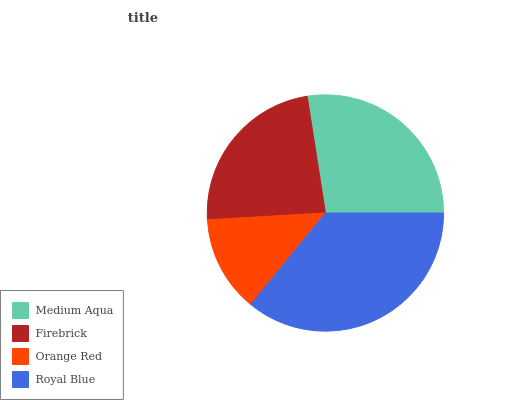Is Orange Red the minimum?
Answer yes or no. Yes. Is Royal Blue the maximum?
Answer yes or no. Yes. Is Firebrick the minimum?
Answer yes or no. No. Is Firebrick the maximum?
Answer yes or no. No. Is Medium Aqua greater than Firebrick?
Answer yes or no. Yes. Is Firebrick less than Medium Aqua?
Answer yes or no. Yes. Is Firebrick greater than Medium Aqua?
Answer yes or no. No. Is Medium Aqua less than Firebrick?
Answer yes or no. No. Is Medium Aqua the high median?
Answer yes or no. Yes. Is Firebrick the low median?
Answer yes or no. Yes. Is Firebrick the high median?
Answer yes or no. No. Is Medium Aqua the low median?
Answer yes or no. No. 